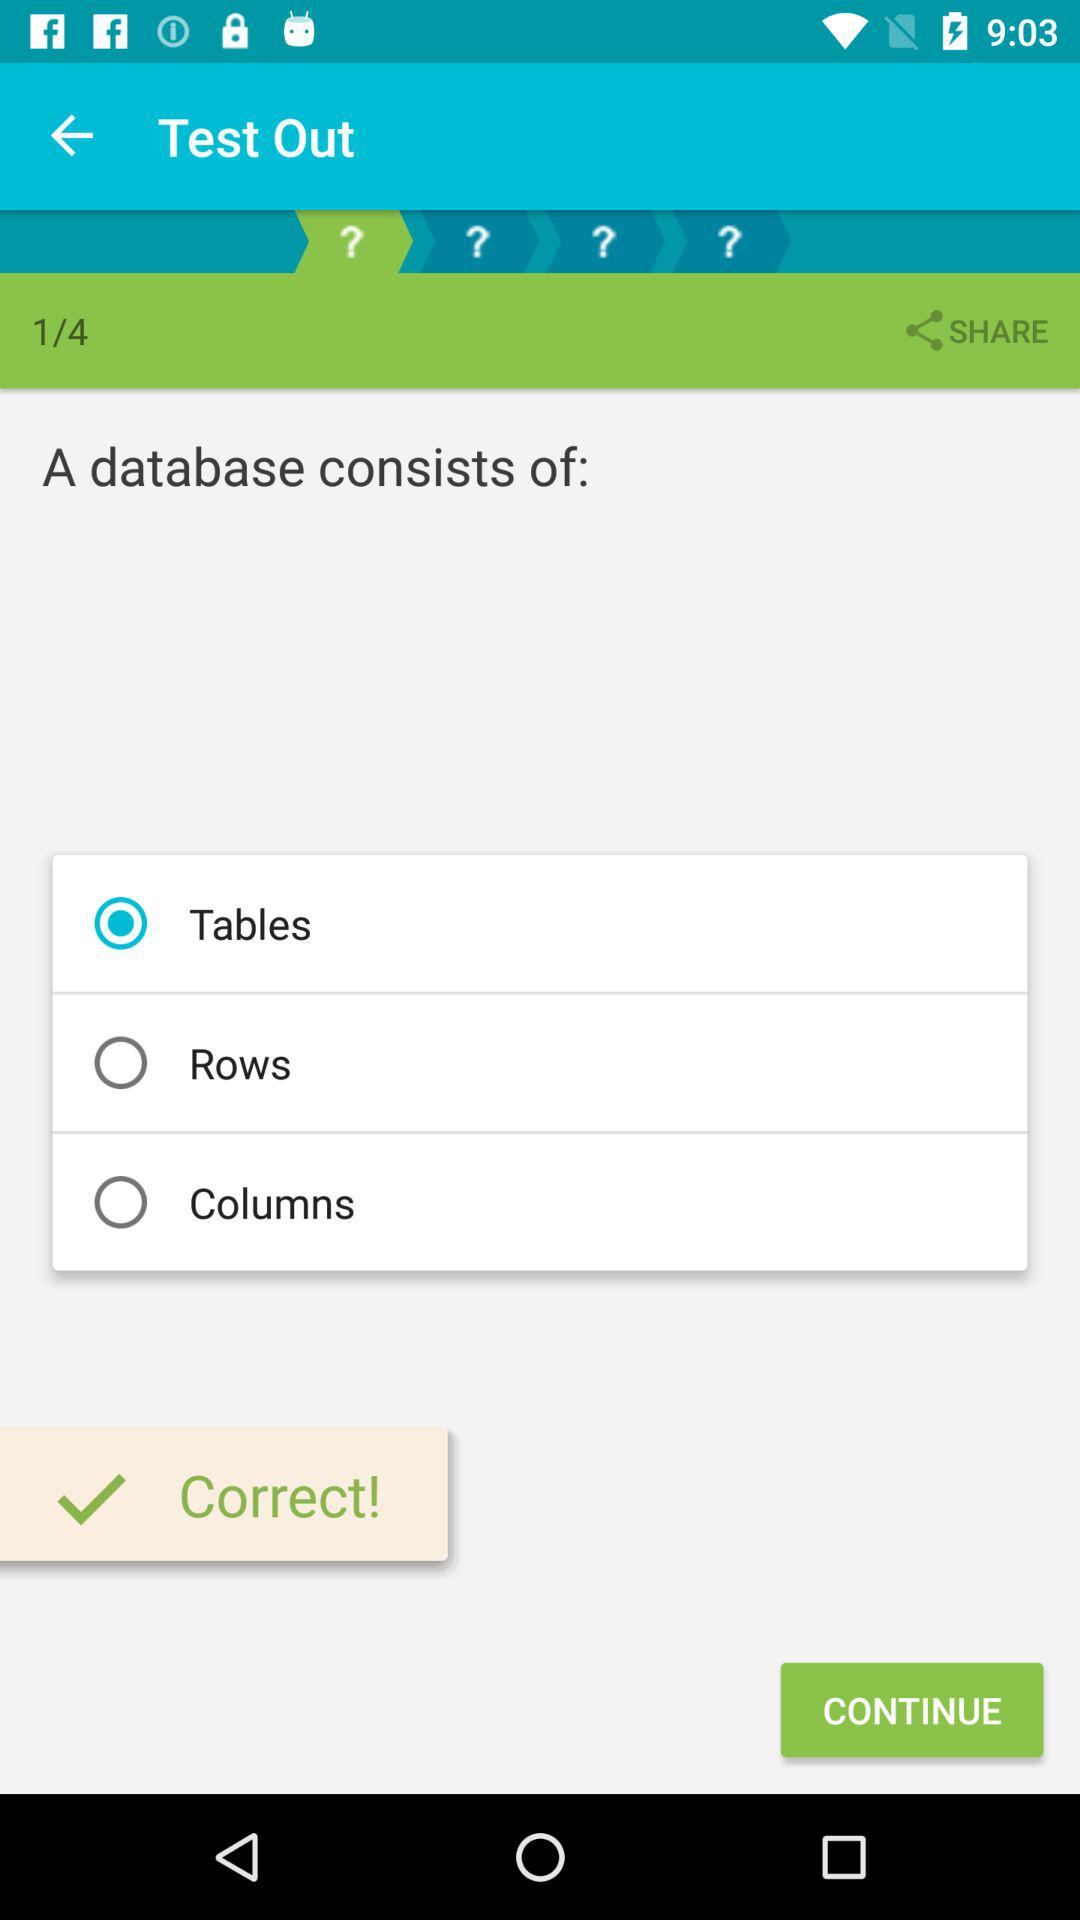What does a database consist of? A database consists of tables. 